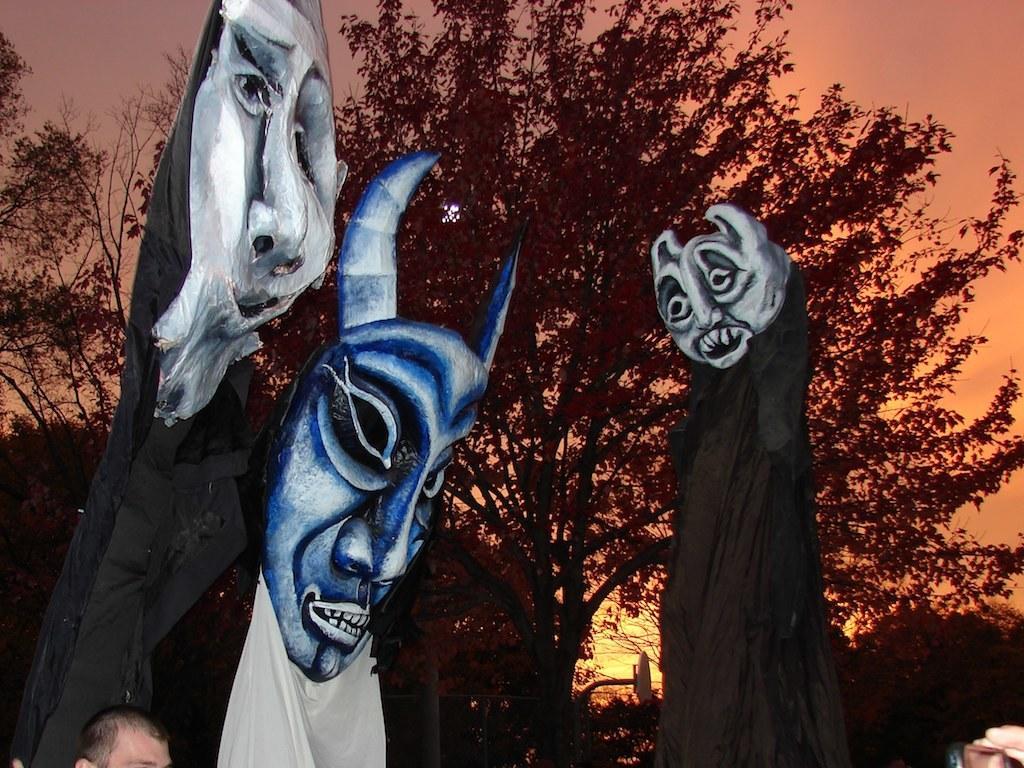Could you give a brief overview of what you see in this image? This picture is clicked outside. In the foreground we can see the clothes and the masks and there are some persons. In the background there is a sky, trees and some other items. 